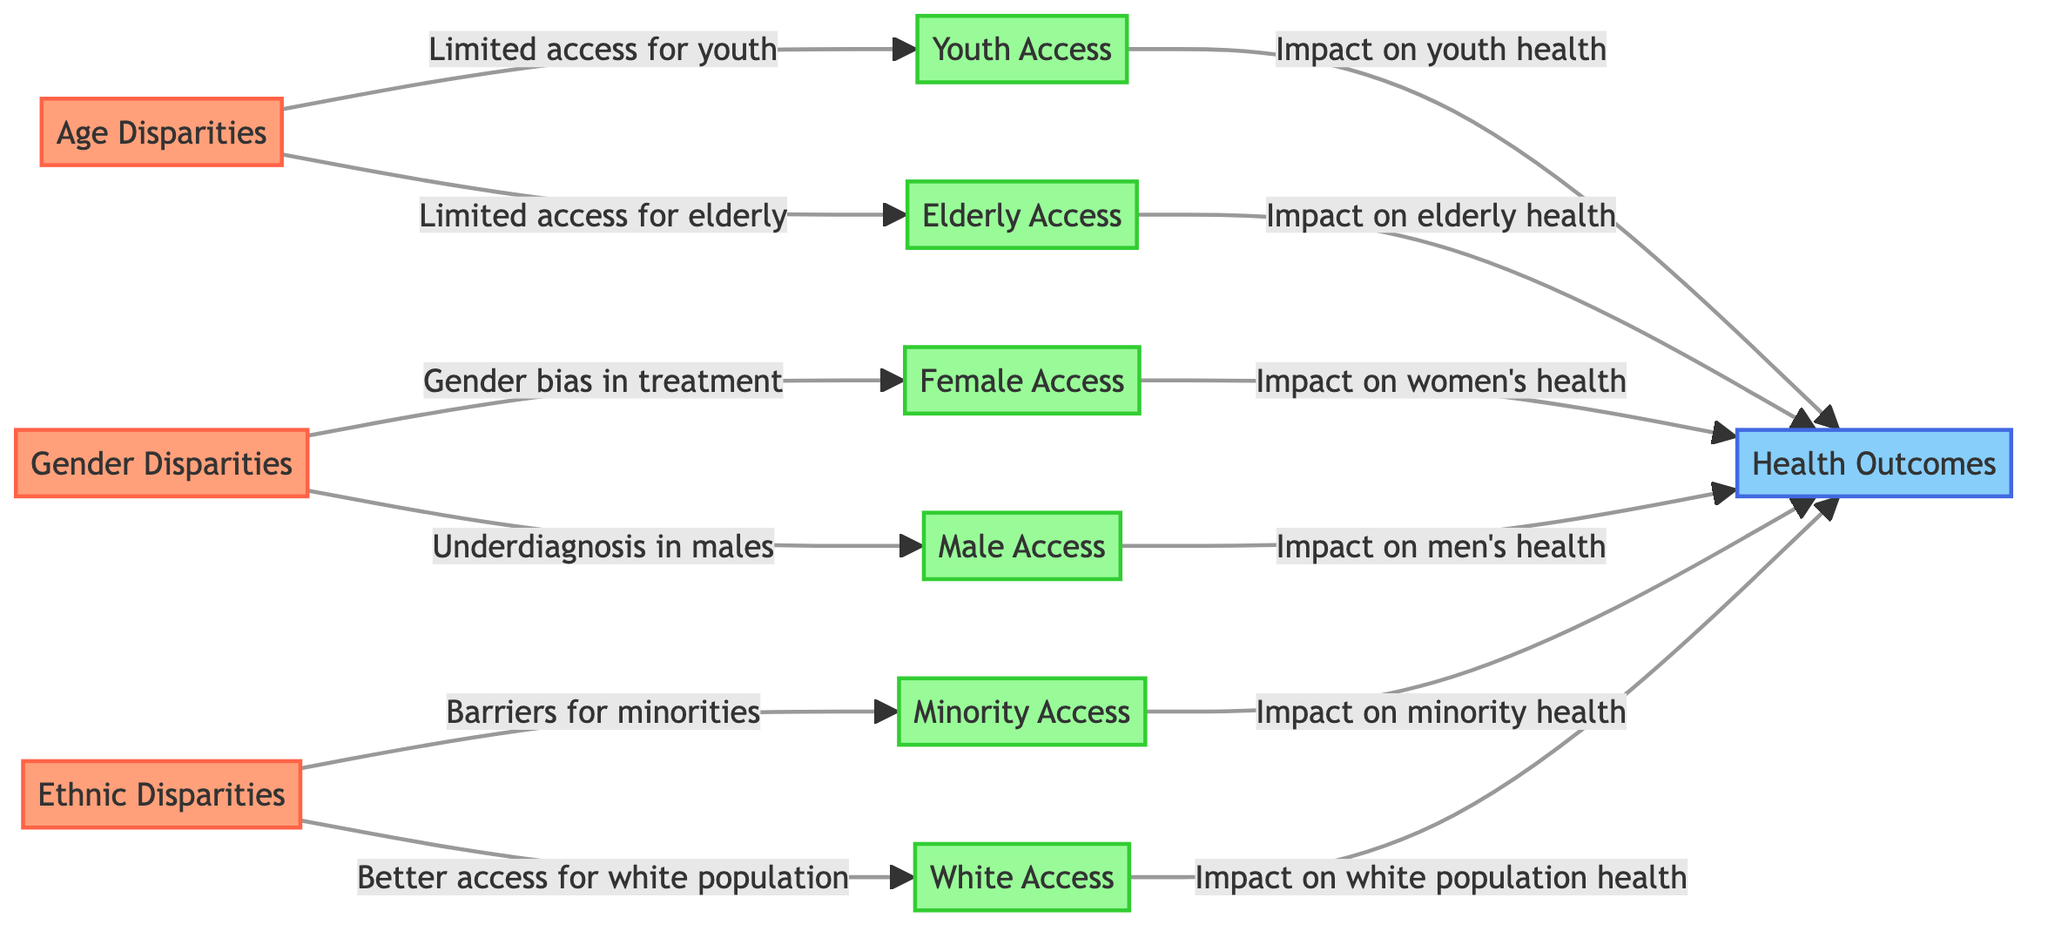What are the three main disparities identified in the diagram? The diagram identifies "Age Disparities," "Gender Disparities," and "Ethnic Disparities" as the three primary disparities that affect healthcare access.
Answer: Age Disparities, Gender Disparities, Ethnic Disparities Which group has limited access according to the age disparities? The age disparities node directly points to "Limited access for youth" and "Limited access for elderly," indicating both youth and elderly groups face access issues.
Answer: Youth, Elderly What impact does limited access for minorities have? The diagram shows that "Barriers for minorities" leads to an effect on health outcomes, specifically indicating that it impacts "Minority health."
Answer: Impact on minority health How many access categories are there for gender disparities? The gender disparities node connects to two specific access categories: "Female Access" and "Male Access," indicating there are two categories related to gender disparities.
Answer: Two What is the relationship between elderly access and health outcomes? "Elderly Access" is pointed out to have a direct arrow towards "Health Outcomes," indicating that the access level for elderly individuals affects their overall health outcomes.
Answer: Impact on elderly health How many total access categories are represented in this diagram? By counting the access categories: "Youth Access," "Elderly Access," "Female Access," "Male Access," "Minority Access," and "White Access," we find a total of six unique access categories.
Answer: Six What does the diagram suggest about access for the white population? The diagram states that "Better access for white population" leads to an influence on "White population health," implying that white individuals generally face fewer barriers to healthcare access.
Answer: Better access for white population What is the significance of the connections depicted in the diagram? The arrows in the diagram represent causal relationships where disparities lead to limited access, which then influences overall health outcomes, thus illustrating the chain of impact from disparities to health consequences.
Answer: Causal relationships 